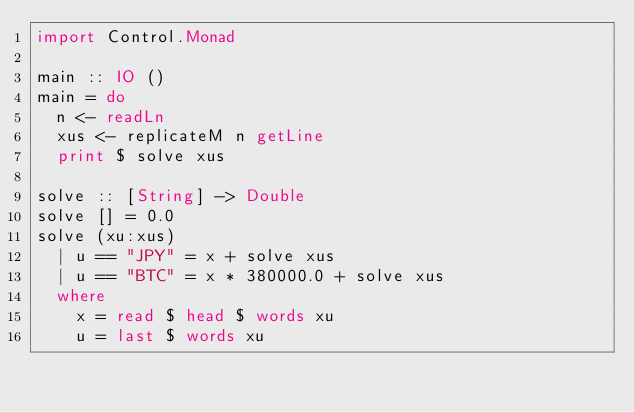Convert code to text. <code><loc_0><loc_0><loc_500><loc_500><_Haskell_>import Control.Monad

main :: IO ()
main = do
  n <- readLn
  xus <- replicateM n getLine
  print $ solve xus

solve :: [String] -> Double
solve [] = 0.0
solve (xu:xus)
  | u == "JPY" = x + solve xus
  | u == "BTC" = x * 380000.0 + solve xus
  where
    x = read $ head $ words xu
    u = last $ words xu
  
</code> 